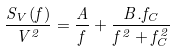<formula> <loc_0><loc_0><loc_500><loc_500>\frac { S _ { V } ( f ) } { V ^ { 2 } } = \frac { A } { f } + \frac { B . f _ { C } } { f ^ { 2 } + f _ { C } ^ { 2 } }</formula> 